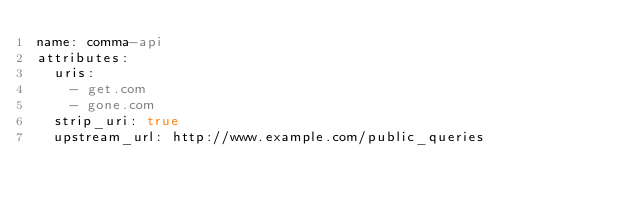Convert code to text. <code><loc_0><loc_0><loc_500><loc_500><_YAML_>name: comma-api
attributes:
  uris: 
    - get.com
    - gone.com
  strip_uri: true
  upstream_url: http://www.example.com/public_queries
</code> 